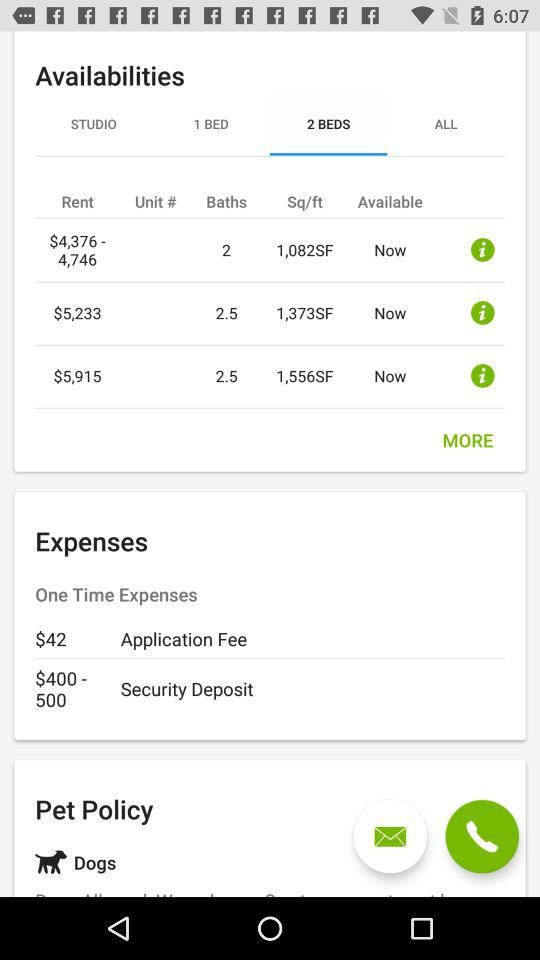How many more square feet are there in the largest apartment than the smallest?
Answer the question using a single word or phrase. 474 